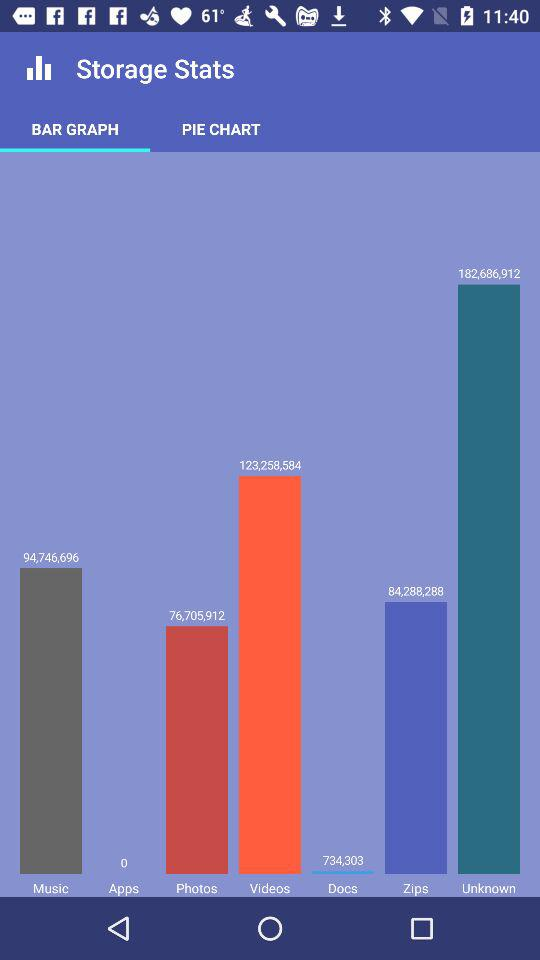Which bar graph has the most numbers?
When the provided information is insufficient, respond with <no answer>. <no answer> 